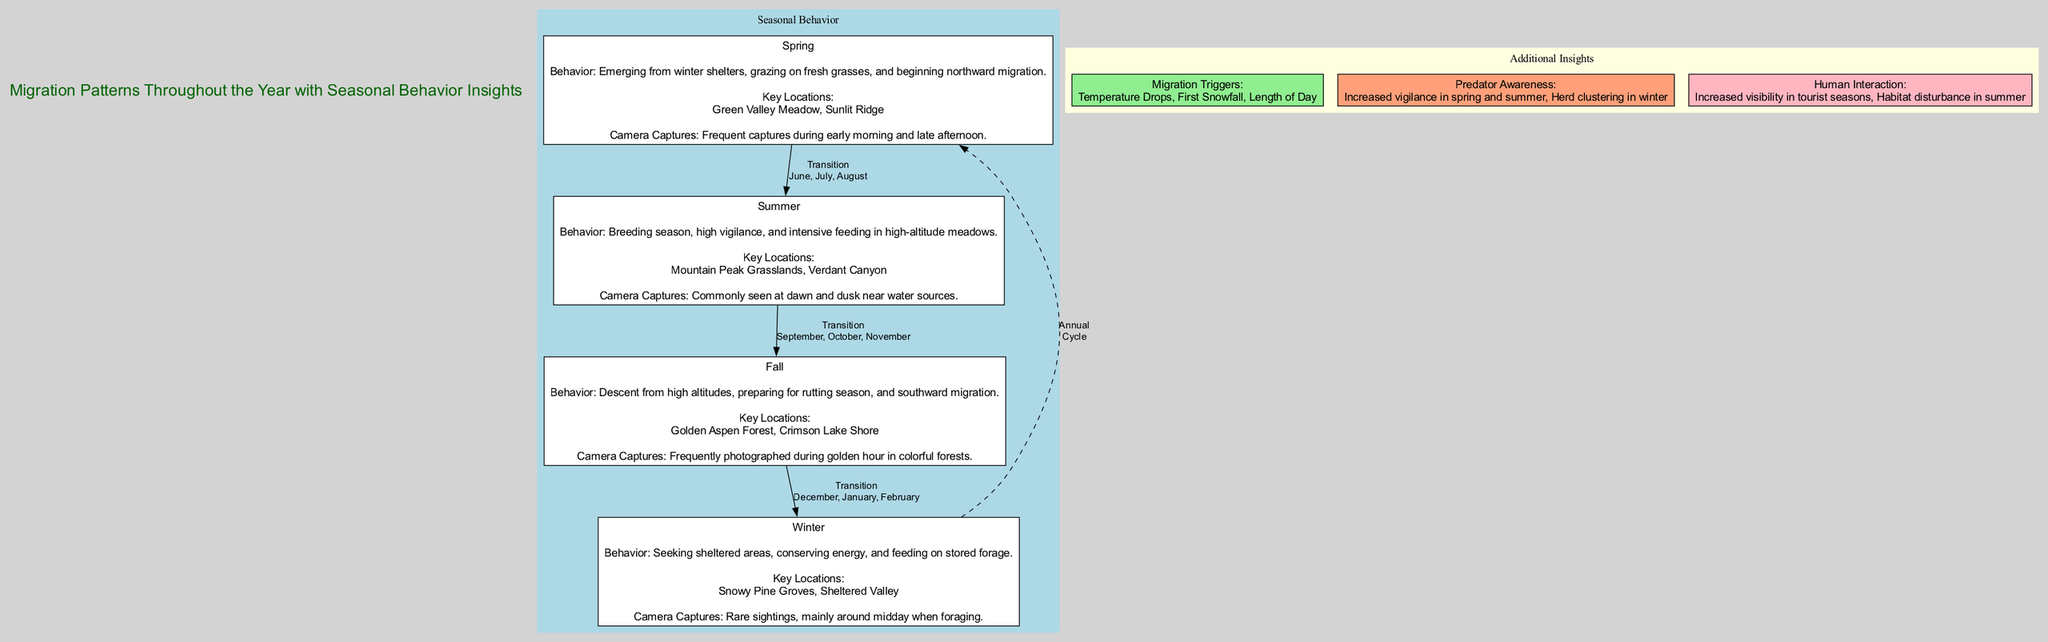What are the key locations in Spring? In the Spring phase, the diagram specifies two key locations: "Green Valley Meadow" and "Sunlit Ridge". These locations are directly noted under the Spring section of the visual information.
Answer: Green Valley Meadow, Sunlit Ridge How many months are in the Fall season? The Fall phase includes the months of "September, October, and November", which totals three months. This information is clearly identified in the diagram under the Fall section.
Answer: 3 What behavior is associated with the Summer season? The Summer phase describes the behavior as "Breeding season, high vigilance, and intensive feeding in high-altitude meadows". This specific description can be found in the Summer section of the diagram.
Answer: Breeding season, high vigilance, and intensive feeding in high-altitude meadows Which season is associated with 'rarest sightings'? The Winter phase is noted for having "rare sightings, mainly around midday when foraging". This information indicates that the Winter season is the one with the least visual encounters, as stated in the diagram.
Answer: Winter What triggers migration according to the diagram? The migration triggers listed in the diagram are "Temperature Drops, First Snowfall, Length of Day". These elements are categorized under additional insights section, which highlights the factors influencing the elk’s migration patterns.
Answer: Temperature Drops, First Snowfall, Length of Day What connections exist between Winter and Spring? According to the diagram, there is a "Annual Cycle" connection between Winter and Spring, represented with a dashed edge. This indicates that after the Winter phase, the cycle returns to Spring, completing the seasonal loop.
Answer: Annual Cycle How is predator awareness categorized in terms of seasons? The diagram indicates that predator awareness involves "Increased vigilance in spring and summer" and "Herd clustering in winter", showing a seasonal variance in behavior related to predator threats.
Answer: Increased vigilance in spring and summer, Herd clustering in winter What is the primary camera capture time in Fall? The diagram notes that elk are "Frequently photographed during golden hour in colorful forests" during the Fall phase, indicating that this time of day is significant for capturing images of the elk.
Answer: Golden hour How many primary phases are depicted in the diagram? The diagram outlines four primary phases: Spring, Summer, Fall, and Winter. This division is clearly marked, making it easy to count the distinct seasons represented.
Answer: 4 